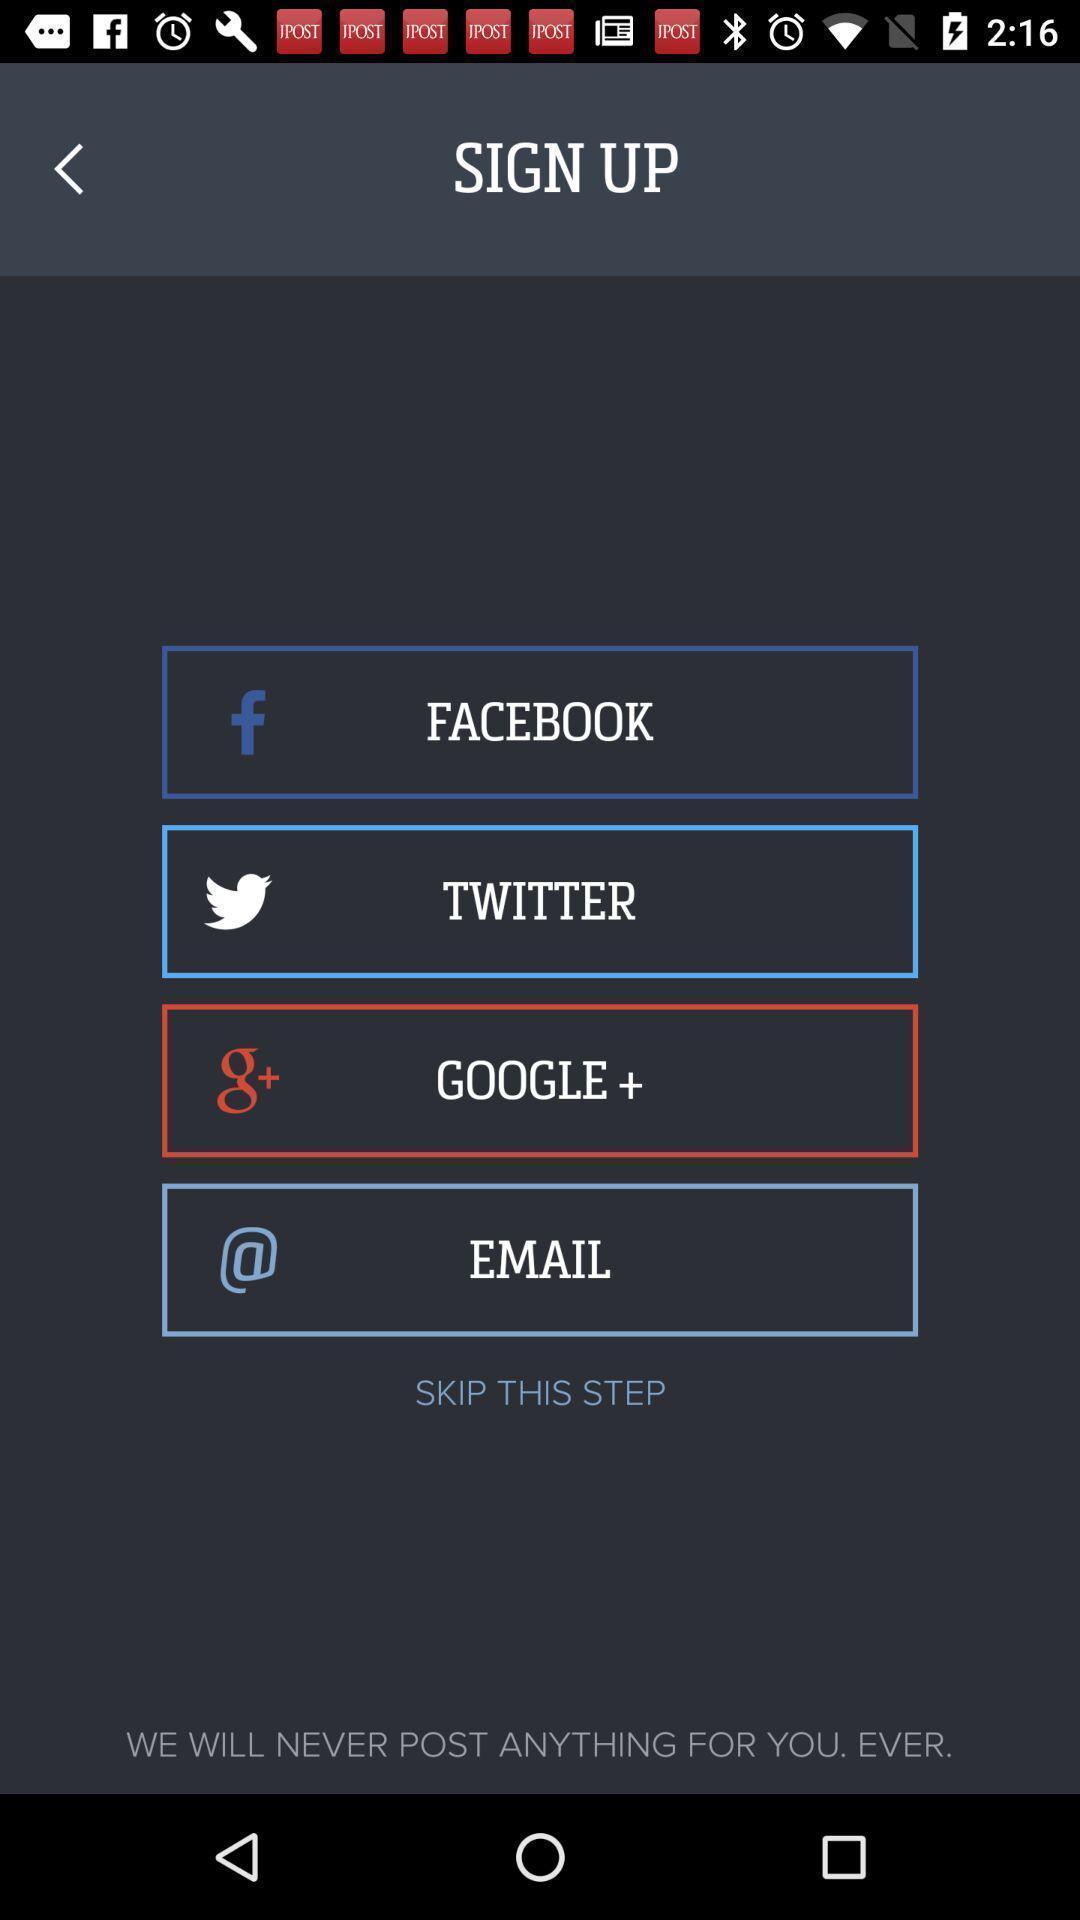What can you discern from this picture? Sign up page. 